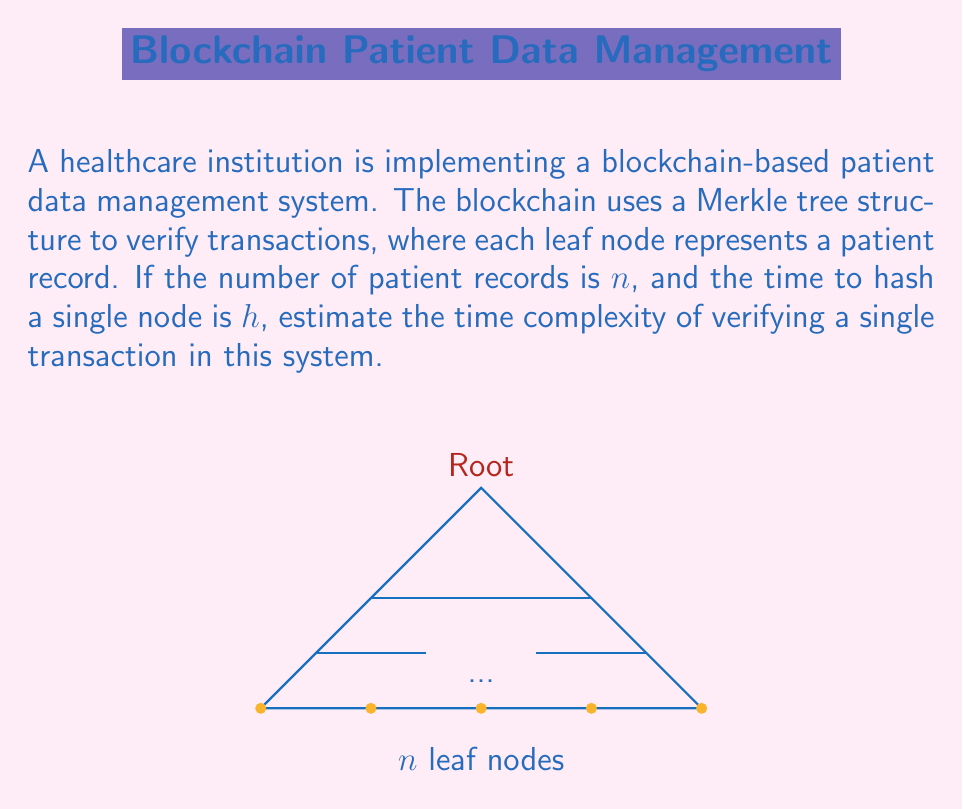Could you help me with this problem? To estimate the time complexity of verifying a single transaction in this blockchain system, we need to consider the structure of the Merkle tree and the verification process:

1) In a Merkle tree, the number of levels is logarithmic to the number of leaf nodes. The height of the tree is $\log_2(n)$, where $n$ is the number of patient records.

2) To verify a transaction, we need to compute the path from a leaf node (patient record) to the root of the Merkle tree. This involves computing hashes at each level of the tree.

3) At each level, we need to perform one hash operation. The number of hash operations is equal to the height of the tree.

4) Therefore, the number of hash operations required is $\log_2(n)$.

5) If each hash operation takes time $h$, the total time for verification is $h \cdot \log_2(n)$.

6) In Big O notation, we ignore constant factors. The time complexity is thus $O(\log n)$.

This logarithmic time complexity is one of the key advantages of using Merkle trees in blockchain systems, as it allows for efficient verification even with large datasets.
Answer: $O(\log n)$ 